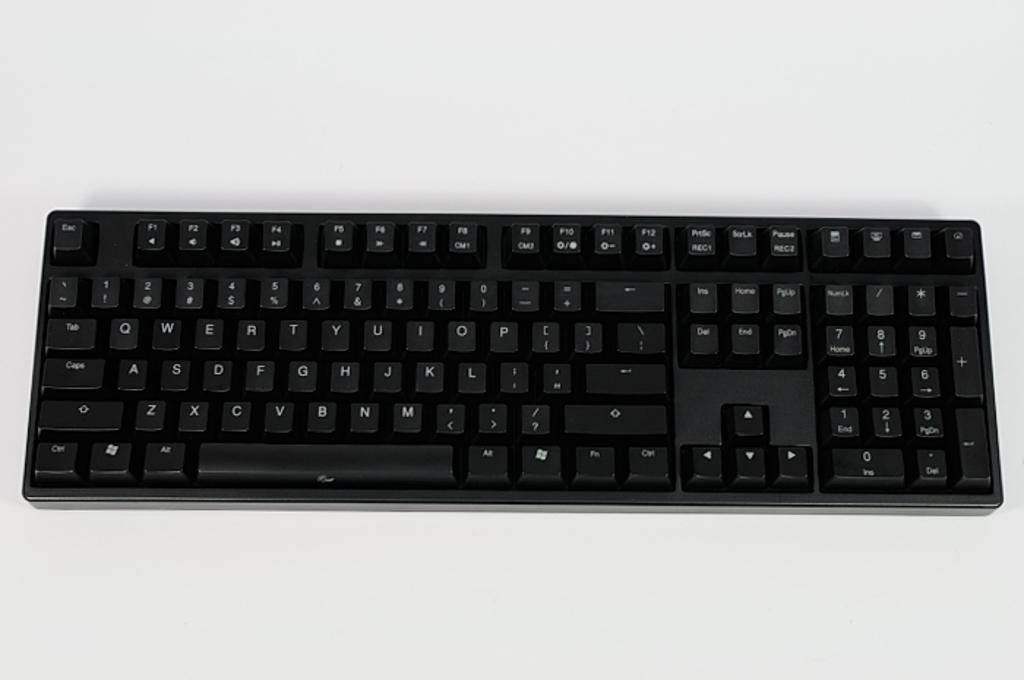What letters are on the key on the top left?
Keep it short and to the point. Esc. Is this a qwerty keyboard?
Offer a very short reply. Yes. 